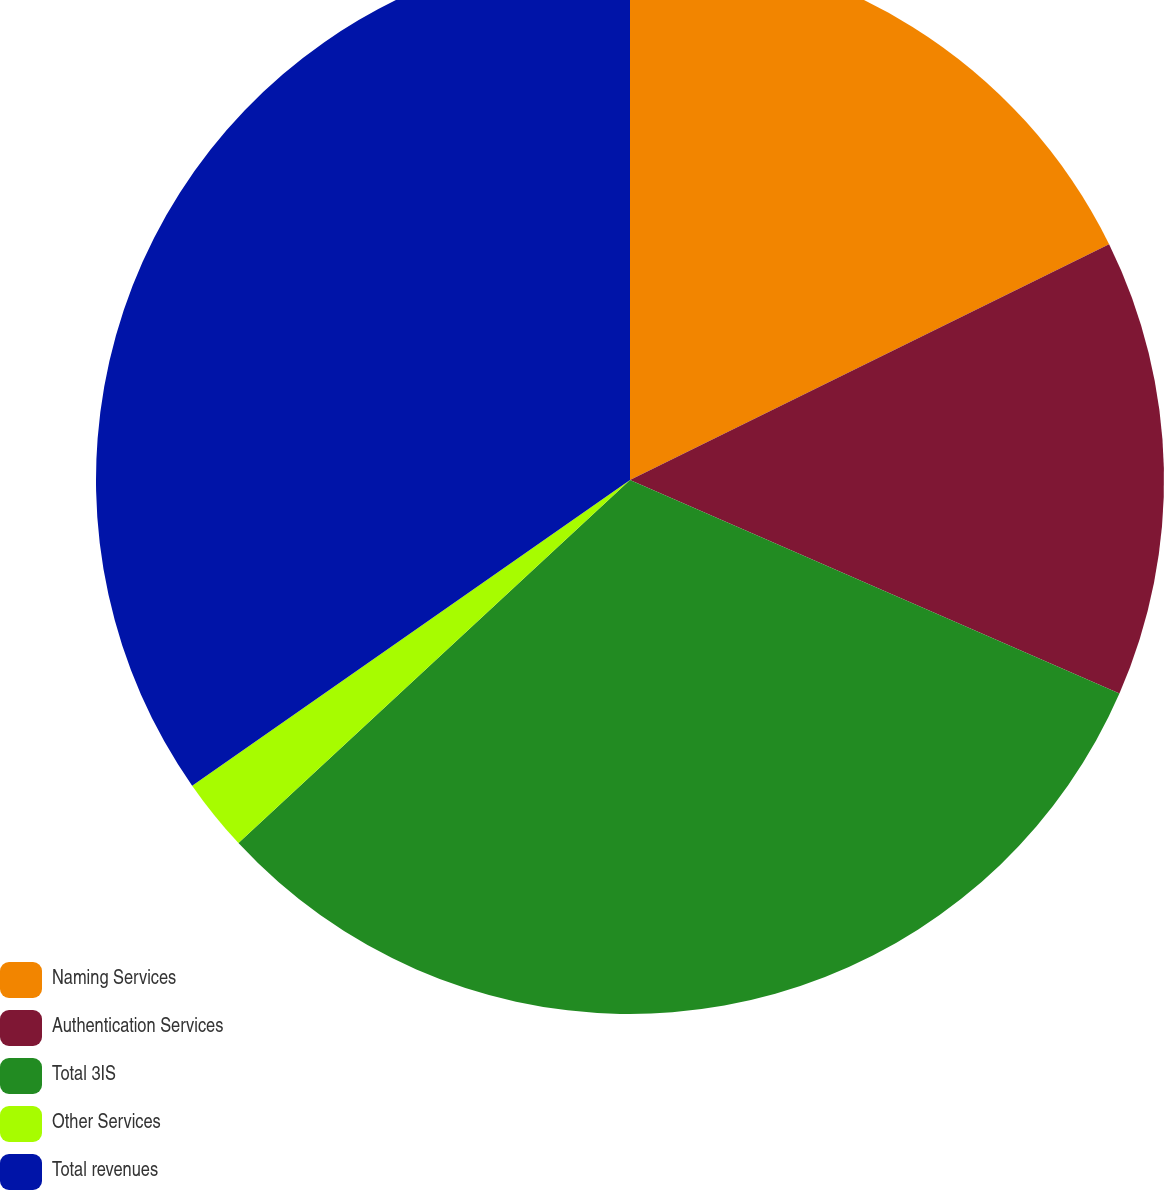<chart> <loc_0><loc_0><loc_500><loc_500><pie_chart><fcel>Naming Services<fcel>Authentication Services<fcel>Total 3IS<fcel>Other Services<fcel>Total revenues<nl><fcel>17.72%<fcel>13.83%<fcel>31.55%<fcel>2.2%<fcel>34.7%<nl></chart> 